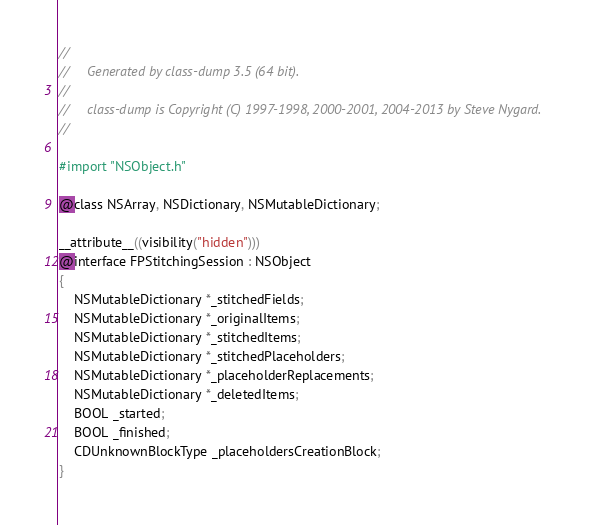Convert code to text. <code><loc_0><loc_0><loc_500><loc_500><_C_>//
//     Generated by class-dump 3.5 (64 bit).
//
//     class-dump is Copyright (C) 1997-1998, 2000-2001, 2004-2013 by Steve Nygard.
//

#import "NSObject.h"

@class NSArray, NSDictionary, NSMutableDictionary;

__attribute__((visibility("hidden")))
@interface FPStitchingSession : NSObject
{
    NSMutableDictionary *_stitchedFields;
    NSMutableDictionary *_originalItems;
    NSMutableDictionary *_stitchedItems;
    NSMutableDictionary *_stitchedPlaceholders;
    NSMutableDictionary *_placeholderReplacements;
    NSMutableDictionary *_deletedItems;
    BOOL _started;
    BOOL _finished;
    CDUnknownBlockType _placeholdersCreationBlock;
}
</code> 